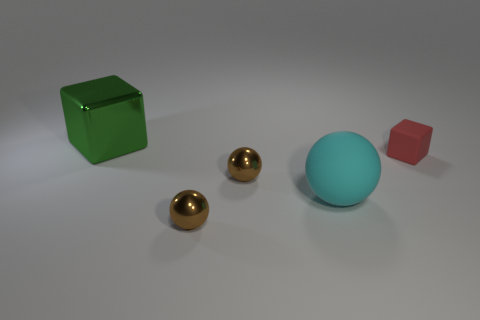What is the size of the cube right of the thing that is behind the tiny rubber block?
Your response must be concise. Small. There is a tiny shiny thing in front of the large sphere; is it the same color as the large object that is right of the green metal cube?
Your response must be concise. No. There is a metal object that is both behind the big cyan matte sphere and in front of the large green metal block; what is its color?
Offer a very short reply. Brown. Are the green cube and the cyan ball made of the same material?
Your answer should be compact. No. How many big things are either rubber spheres or yellow cylinders?
Keep it short and to the point. 1. Are there any other things that are the same shape as the cyan matte thing?
Your response must be concise. Yes. The thing that is the same material as the cyan sphere is what color?
Make the answer very short. Red. What color is the cube on the right side of the big shiny block?
Your response must be concise. Red. Is the number of rubber blocks behind the large metallic object less than the number of tiny cubes on the right side of the red block?
Provide a short and direct response. No. How many things are to the left of the red object?
Your response must be concise. 4. 